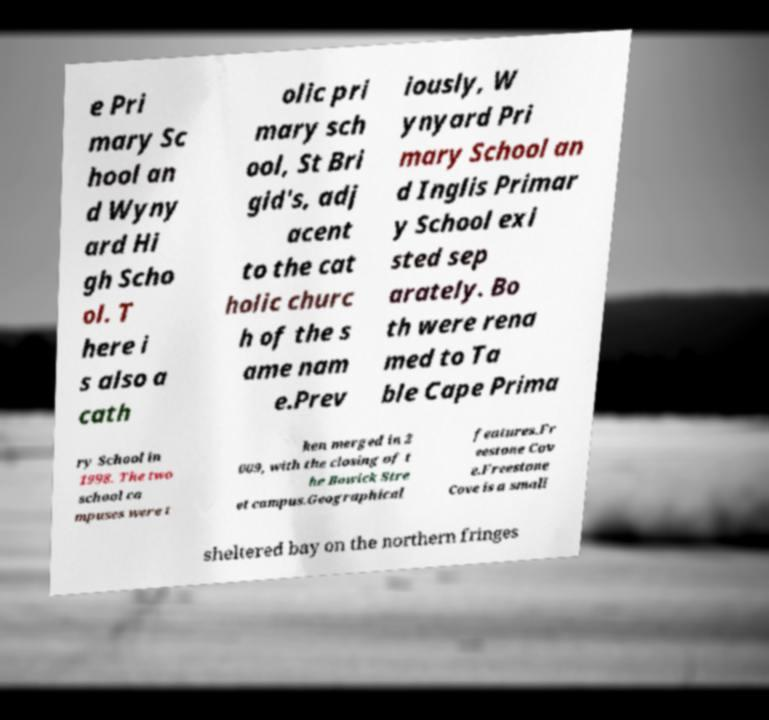Could you assist in decoding the text presented in this image and type it out clearly? e Pri mary Sc hool an d Wyny ard Hi gh Scho ol. T here i s also a cath olic pri mary sch ool, St Bri gid's, adj acent to the cat holic churc h of the s ame nam e.Prev iously, W ynyard Pri mary School an d Inglis Primar y School exi sted sep arately. Bo th were rena med to Ta ble Cape Prima ry School in 1998. The two school ca mpuses were t hen merged in 2 009, with the closing of t he Bowick Stre et campus.Geographical features.Fr eestone Cov e.Freestone Cove is a small sheltered bay on the northern fringes 